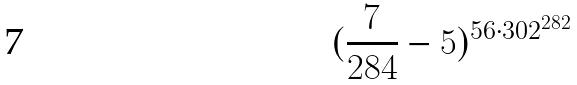<formula> <loc_0><loc_0><loc_500><loc_500>( \frac { 7 } { 2 8 4 } - 5 ) ^ { 5 6 \cdot 3 0 2 ^ { 2 8 2 } }</formula> 